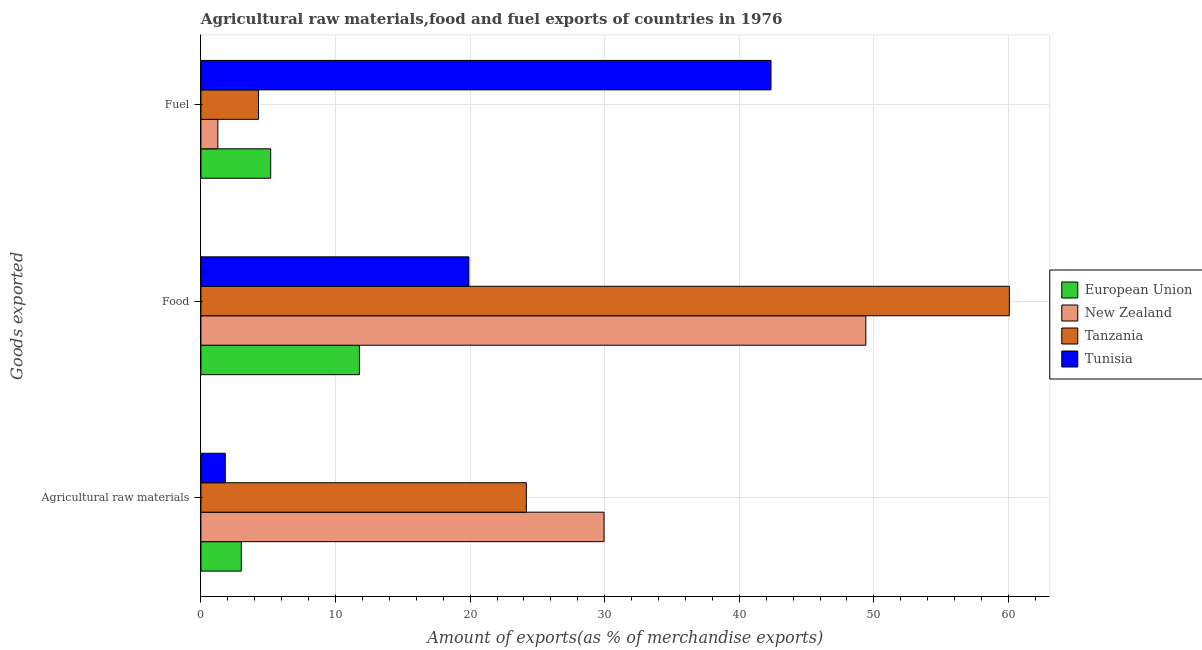Are the number of bars per tick equal to the number of legend labels?
Ensure brevity in your answer.  Yes. How many bars are there on the 1st tick from the top?
Provide a short and direct response. 4. What is the label of the 3rd group of bars from the top?
Keep it short and to the point. Agricultural raw materials. What is the percentage of raw materials exports in New Zealand?
Your answer should be very brief. 29.95. Across all countries, what is the maximum percentage of fuel exports?
Keep it short and to the point. 42.36. Across all countries, what is the minimum percentage of food exports?
Your response must be concise. 11.78. In which country was the percentage of food exports maximum?
Provide a short and direct response. Tanzania. In which country was the percentage of fuel exports minimum?
Offer a terse response. New Zealand. What is the total percentage of fuel exports in the graph?
Offer a terse response. 53.08. What is the difference between the percentage of raw materials exports in European Union and that in Tanzania?
Provide a succinct answer. -21.18. What is the difference between the percentage of raw materials exports in Tanzania and the percentage of food exports in Tunisia?
Offer a terse response. 4.27. What is the average percentage of raw materials exports per country?
Ensure brevity in your answer.  14.73. What is the difference between the percentage of raw materials exports and percentage of fuel exports in European Union?
Make the answer very short. -2.18. What is the ratio of the percentage of fuel exports in Tunisia to that in New Zealand?
Offer a very short reply. 33.65. Is the percentage of food exports in European Union less than that in New Zealand?
Provide a short and direct response. Yes. What is the difference between the highest and the second highest percentage of food exports?
Make the answer very short. 10.66. What is the difference between the highest and the lowest percentage of raw materials exports?
Give a very brief answer. 28.14. In how many countries, is the percentage of raw materials exports greater than the average percentage of raw materials exports taken over all countries?
Provide a succinct answer. 2. Is the sum of the percentage of raw materials exports in New Zealand and Tunisia greater than the maximum percentage of fuel exports across all countries?
Provide a succinct answer. No. What does the 2nd bar from the top in Agricultural raw materials represents?
Provide a short and direct response. Tanzania. What does the 4th bar from the bottom in Food represents?
Make the answer very short. Tunisia. What is the difference between two consecutive major ticks on the X-axis?
Keep it short and to the point. 10. How many legend labels are there?
Offer a terse response. 4. What is the title of the graph?
Your answer should be very brief. Agricultural raw materials,food and fuel exports of countries in 1976. Does "Macao" appear as one of the legend labels in the graph?
Offer a very short reply. No. What is the label or title of the X-axis?
Provide a succinct answer. Amount of exports(as % of merchandise exports). What is the label or title of the Y-axis?
Offer a terse response. Goods exported. What is the Amount of exports(as % of merchandise exports) in European Union in Agricultural raw materials?
Keep it short and to the point. 3. What is the Amount of exports(as % of merchandise exports) in New Zealand in Agricultural raw materials?
Provide a short and direct response. 29.95. What is the Amount of exports(as % of merchandise exports) in Tanzania in Agricultural raw materials?
Offer a very short reply. 24.18. What is the Amount of exports(as % of merchandise exports) of Tunisia in Agricultural raw materials?
Give a very brief answer. 1.81. What is the Amount of exports(as % of merchandise exports) of European Union in Food?
Your answer should be compact. 11.78. What is the Amount of exports(as % of merchandise exports) in New Zealand in Food?
Keep it short and to the point. 49.4. What is the Amount of exports(as % of merchandise exports) in Tanzania in Food?
Your answer should be very brief. 60.06. What is the Amount of exports(as % of merchandise exports) of Tunisia in Food?
Your answer should be very brief. 19.91. What is the Amount of exports(as % of merchandise exports) in European Union in Fuel?
Your response must be concise. 5.18. What is the Amount of exports(as % of merchandise exports) in New Zealand in Fuel?
Offer a terse response. 1.26. What is the Amount of exports(as % of merchandise exports) in Tanzania in Fuel?
Your answer should be very brief. 4.28. What is the Amount of exports(as % of merchandise exports) of Tunisia in Fuel?
Your answer should be compact. 42.36. Across all Goods exported, what is the maximum Amount of exports(as % of merchandise exports) of European Union?
Ensure brevity in your answer.  11.78. Across all Goods exported, what is the maximum Amount of exports(as % of merchandise exports) in New Zealand?
Ensure brevity in your answer.  49.4. Across all Goods exported, what is the maximum Amount of exports(as % of merchandise exports) of Tanzania?
Provide a short and direct response. 60.06. Across all Goods exported, what is the maximum Amount of exports(as % of merchandise exports) of Tunisia?
Make the answer very short. 42.36. Across all Goods exported, what is the minimum Amount of exports(as % of merchandise exports) of European Union?
Offer a terse response. 3. Across all Goods exported, what is the minimum Amount of exports(as % of merchandise exports) in New Zealand?
Provide a succinct answer. 1.26. Across all Goods exported, what is the minimum Amount of exports(as % of merchandise exports) in Tanzania?
Ensure brevity in your answer.  4.28. Across all Goods exported, what is the minimum Amount of exports(as % of merchandise exports) in Tunisia?
Offer a terse response. 1.81. What is the total Amount of exports(as % of merchandise exports) of European Union in the graph?
Provide a short and direct response. 19.96. What is the total Amount of exports(as % of merchandise exports) of New Zealand in the graph?
Your answer should be compact. 80.61. What is the total Amount of exports(as % of merchandise exports) of Tanzania in the graph?
Ensure brevity in your answer.  88.52. What is the total Amount of exports(as % of merchandise exports) in Tunisia in the graph?
Your answer should be compact. 64.07. What is the difference between the Amount of exports(as % of merchandise exports) of European Union in Agricultural raw materials and that in Food?
Give a very brief answer. -8.78. What is the difference between the Amount of exports(as % of merchandise exports) in New Zealand in Agricultural raw materials and that in Food?
Give a very brief answer. -19.45. What is the difference between the Amount of exports(as % of merchandise exports) in Tanzania in Agricultural raw materials and that in Food?
Your answer should be very brief. -35.88. What is the difference between the Amount of exports(as % of merchandise exports) of Tunisia in Agricultural raw materials and that in Food?
Offer a very short reply. -18.1. What is the difference between the Amount of exports(as % of merchandise exports) in European Union in Agricultural raw materials and that in Fuel?
Provide a short and direct response. -2.18. What is the difference between the Amount of exports(as % of merchandise exports) of New Zealand in Agricultural raw materials and that in Fuel?
Ensure brevity in your answer.  28.69. What is the difference between the Amount of exports(as % of merchandise exports) in Tanzania in Agricultural raw materials and that in Fuel?
Provide a succinct answer. 19.9. What is the difference between the Amount of exports(as % of merchandise exports) of Tunisia in Agricultural raw materials and that in Fuel?
Keep it short and to the point. -40.55. What is the difference between the Amount of exports(as % of merchandise exports) of European Union in Food and that in Fuel?
Provide a succinct answer. 6.59. What is the difference between the Amount of exports(as % of merchandise exports) in New Zealand in Food and that in Fuel?
Your answer should be compact. 48.14. What is the difference between the Amount of exports(as % of merchandise exports) of Tanzania in Food and that in Fuel?
Offer a very short reply. 55.78. What is the difference between the Amount of exports(as % of merchandise exports) in Tunisia in Food and that in Fuel?
Your response must be concise. -22.45. What is the difference between the Amount of exports(as % of merchandise exports) in European Union in Agricultural raw materials and the Amount of exports(as % of merchandise exports) in New Zealand in Food?
Provide a succinct answer. -46.4. What is the difference between the Amount of exports(as % of merchandise exports) in European Union in Agricultural raw materials and the Amount of exports(as % of merchandise exports) in Tanzania in Food?
Your answer should be very brief. -57.06. What is the difference between the Amount of exports(as % of merchandise exports) in European Union in Agricultural raw materials and the Amount of exports(as % of merchandise exports) in Tunisia in Food?
Ensure brevity in your answer.  -16.91. What is the difference between the Amount of exports(as % of merchandise exports) of New Zealand in Agricultural raw materials and the Amount of exports(as % of merchandise exports) of Tanzania in Food?
Give a very brief answer. -30.11. What is the difference between the Amount of exports(as % of merchandise exports) of New Zealand in Agricultural raw materials and the Amount of exports(as % of merchandise exports) of Tunisia in Food?
Provide a short and direct response. 10.04. What is the difference between the Amount of exports(as % of merchandise exports) in Tanzania in Agricultural raw materials and the Amount of exports(as % of merchandise exports) in Tunisia in Food?
Your answer should be compact. 4.27. What is the difference between the Amount of exports(as % of merchandise exports) of European Union in Agricultural raw materials and the Amount of exports(as % of merchandise exports) of New Zealand in Fuel?
Provide a short and direct response. 1.74. What is the difference between the Amount of exports(as % of merchandise exports) of European Union in Agricultural raw materials and the Amount of exports(as % of merchandise exports) of Tanzania in Fuel?
Your response must be concise. -1.28. What is the difference between the Amount of exports(as % of merchandise exports) in European Union in Agricultural raw materials and the Amount of exports(as % of merchandise exports) in Tunisia in Fuel?
Your answer should be very brief. -39.35. What is the difference between the Amount of exports(as % of merchandise exports) of New Zealand in Agricultural raw materials and the Amount of exports(as % of merchandise exports) of Tanzania in Fuel?
Keep it short and to the point. 25.67. What is the difference between the Amount of exports(as % of merchandise exports) in New Zealand in Agricultural raw materials and the Amount of exports(as % of merchandise exports) in Tunisia in Fuel?
Keep it short and to the point. -12.41. What is the difference between the Amount of exports(as % of merchandise exports) of Tanzania in Agricultural raw materials and the Amount of exports(as % of merchandise exports) of Tunisia in Fuel?
Offer a terse response. -18.18. What is the difference between the Amount of exports(as % of merchandise exports) in European Union in Food and the Amount of exports(as % of merchandise exports) in New Zealand in Fuel?
Provide a short and direct response. 10.52. What is the difference between the Amount of exports(as % of merchandise exports) in European Union in Food and the Amount of exports(as % of merchandise exports) in Tanzania in Fuel?
Provide a succinct answer. 7.5. What is the difference between the Amount of exports(as % of merchandise exports) in European Union in Food and the Amount of exports(as % of merchandise exports) in Tunisia in Fuel?
Make the answer very short. -30.58. What is the difference between the Amount of exports(as % of merchandise exports) of New Zealand in Food and the Amount of exports(as % of merchandise exports) of Tanzania in Fuel?
Your answer should be very brief. 45.12. What is the difference between the Amount of exports(as % of merchandise exports) of New Zealand in Food and the Amount of exports(as % of merchandise exports) of Tunisia in Fuel?
Offer a very short reply. 7.05. What is the difference between the Amount of exports(as % of merchandise exports) in Tanzania in Food and the Amount of exports(as % of merchandise exports) in Tunisia in Fuel?
Your response must be concise. 17.71. What is the average Amount of exports(as % of merchandise exports) of European Union per Goods exported?
Provide a short and direct response. 6.65. What is the average Amount of exports(as % of merchandise exports) in New Zealand per Goods exported?
Ensure brevity in your answer.  26.87. What is the average Amount of exports(as % of merchandise exports) of Tanzania per Goods exported?
Provide a short and direct response. 29.51. What is the average Amount of exports(as % of merchandise exports) in Tunisia per Goods exported?
Make the answer very short. 21.36. What is the difference between the Amount of exports(as % of merchandise exports) of European Union and Amount of exports(as % of merchandise exports) of New Zealand in Agricultural raw materials?
Ensure brevity in your answer.  -26.95. What is the difference between the Amount of exports(as % of merchandise exports) in European Union and Amount of exports(as % of merchandise exports) in Tanzania in Agricultural raw materials?
Make the answer very short. -21.18. What is the difference between the Amount of exports(as % of merchandise exports) in European Union and Amount of exports(as % of merchandise exports) in Tunisia in Agricultural raw materials?
Offer a terse response. 1.19. What is the difference between the Amount of exports(as % of merchandise exports) of New Zealand and Amount of exports(as % of merchandise exports) of Tanzania in Agricultural raw materials?
Give a very brief answer. 5.77. What is the difference between the Amount of exports(as % of merchandise exports) of New Zealand and Amount of exports(as % of merchandise exports) of Tunisia in Agricultural raw materials?
Keep it short and to the point. 28.14. What is the difference between the Amount of exports(as % of merchandise exports) in Tanzania and Amount of exports(as % of merchandise exports) in Tunisia in Agricultural raw materials?
Offer a very short reply. 22.37. What is the difference between the Amount of exports(as % of merchandise exports) in European Union and Amount of exports(as % of merchandise exports) in New Zealand in Food?
Your answer should be very brief. -37.62. What is the difference between the Amount of exports(as % of merchandise exports) of European Union and Amount of exports(as % of merchandise exports) of Tanzania in Food?
Give a very brief answer. -48.29. What is the difference between the Amount of exports(as % of merchandise exports) of European Union and Amount of exports(as % of merchandise exports) of Tunisia in Food?
Make the answer very short. -8.13. What is the difference between the Amount of exports(as % of merchandise exports) in New Zealand and Amount of exports(as % of merchandise exports) in Tanzania in Food?
Your answer should be very brief. -10.66. What is the difference between the Amount of exports(as % of merchandise exports) of New Zealand and Amount of exports(as % of merchandise exports) of Tunisia in Food?
Make the answer very short. 29.49. What is the difference between the Amount of exports(as % of merchandise exports) of Tanzania and Amount of exports(as % of merchandise exports) of Tunisia in Food?
Offer a terse response. 40.15. What is the difference between the Amount of exports(as % of merchandise exports) of European Union and Amount of exports(as % of merchandise exports) of New Zealand in Fuel?
Give a very brief answer. 3.92. What is the difference between the Amount of exports(as % of merchandise exports) in European Union and Amount of exports(as % of merchandise exports) in Tanzania in Fuel?
Your response must be concise. 0.91. What is the difference between the Amount of exports(as % of merchandise exports) in European Union and Amount of exports(as % of merchandise exports) in Tunisia in Fuel?
Offer a terse response. -37.17. What is the difference between the Amount of exports(as % of merchandise exports) in New Zealand and Amount of exports(as % of merchandise exports) in Tanzania in Fuel?
Your response must be concise. -3.02. What is the difference between the Amount of exports(as % of merchandise exports) in New Zealand and Amount of exports(as % of merchandise exports) in Tunisia in Fuel?
Keep it short and to the point. -41.1. What is the difference between the Amount of exports(as % of merchandise exports) in Tanzania and Amount of exports(as % of merchandise exports) in Tunisia in Fuel?
Your response must be concise. -38.08. What is the ratio of the Amount of exports(as % of merchandise exports) of European Union in Agricultural raw materials to that in Food?
Your response must be concise. 0.25. What is the ratio of the Amount of exports(as % of merchandise exports) in New Zealand in Agricultural raw materials to that in Food?
Keep it short and to the point. 0.61. What is the ratio of the Amount of exports(as % of merchandise exports) in Tanzania in Agricultural raw materials to that in Food?
Ensure brevity in your answer.  0.4. What is the ratio of the Amount of exports(as % of merchandise exports) in Tunisia in Agricultural raw materials to that in Food?
Offer a very short reply. 0.09. What is the ratio of the Amount of exports(as % of merchandise exports) of European Union in Agricultural raw materials to that in Fuel?
Your answer should be compact. 0.58. What is the ratio of the Amount of exports(as % of merchandise exports) in New Zealand in Agricultural raw materials to that in Fuel?
Your answer should be compact. 23.79. What is the ratio of the Amount of exports(as % of merchandise exports) of Tanzania in Agricultural raw materials to that in Fuel?
Your answer should be compact. 5.65. What is the ratio of the Amount of exports(as % of merchandise exports) of Tunisia in Agricultural raw materials to that in Fuel?
Offer a very short reply. 0.04. What is the ratio of the Amount of exports(as % of merchandise exports) of European Union in Food to that in Fuel?
Offer a terse response. 2.27. What is the ratio of the Amount of exports(as % of merchandise exports) in New Zealand in Food to that in Fuel?
Ensure brevity in your answer.  39.24. What is the ratio of the Amount of exports(as % of merchandise exports) in Tanzania in Food to that in Fuel?
Give a very brief answer. 14.04. What is the ratio of the Amount of exports(as % of merchandise exports) of Tunisia in Food to that in Fuel?
Ensure brevity in your answer.  0.47. What is the difference between the highest and the second highest Amount of exports(as % of merchandise exports) in European Union?
Provide a succinct answer. 6.59. What is the difference between the highest and the second highest Amount of exports(as % of merchandise exports) in New Zealand?
Offer a terse response. 19.45. What is the difference between the highest and the second highest Amount of exports(as % of merchandise exports) in Tanzania?
Your response must be concise. 35.88. What is the difference between the highest and the second highest Amount of exports(as % of merchandise exports) in Tunisia?
Ensure brevity in your answer.  22.45. What is the difference between the highest and the lowest Amount of exports(as % of merchandise exports) in European Union?
Keep it short and to the point. 8.78. What is the difference between the highest and the lowest Amount of exports(as % of merchandise exports) in New Zealand?
Make the answer very short. 48.14. What is the difference between the highest and the lowest Amount of exports(as % of merchandise exports) in Tanzania?
Your response must be concise. 55.78. What is the difference between the highest and the lowest Amount of exports(as % of merchandise exports) of Tunisia?
Give a very brief answer. 40.55. 